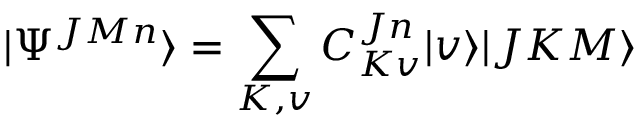<formula> <loc_0><loc_0><loc_500><loc_500>| \Psi ^ { J M n } \rangle = \sum _ { K , v } { C _ { K v } ^ { J n } | v \rangle | J K M \rangle }</formula> 